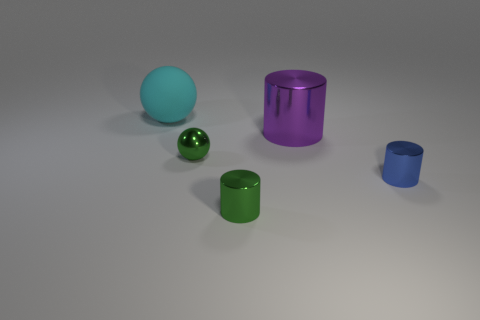What is the size of the thing that is the same color as the small ball?
Give a very brief answer. Small. There is a metallic thing to the right of the big purple shiny thing; what is its size?
Your answer should be very brief. Small. What number of tiny things are the same color as the tiny sphere?
Provide a succinct answer. 1. How many cylinders are either blue metallic things or small green things?
Ensure brevity in your answer.  2. The shiny thing that is to the left of the large purple metal thing and behind the green metallic cylinder has what shape?
Give a very brief answer. Sphere. Is there a purple shiny cylinder of the same size as the cyan matte object?
Your answer should be very brief. Yes. What number of things are balls that are in front of the cyan matte ball or small green metallic objects?
Give a very brief answer. 2. Is the blue object made of the same material as the large object that is to the left of the big metal object?
Ensure brevity in your answer.  No. How many other things are the same shape as the purple shiny object?
Give a very brief answer. 2. What number of things are either green things behind the blue metal thing or large things right of the big rubber sphere?
Your response must be concise. 2. 